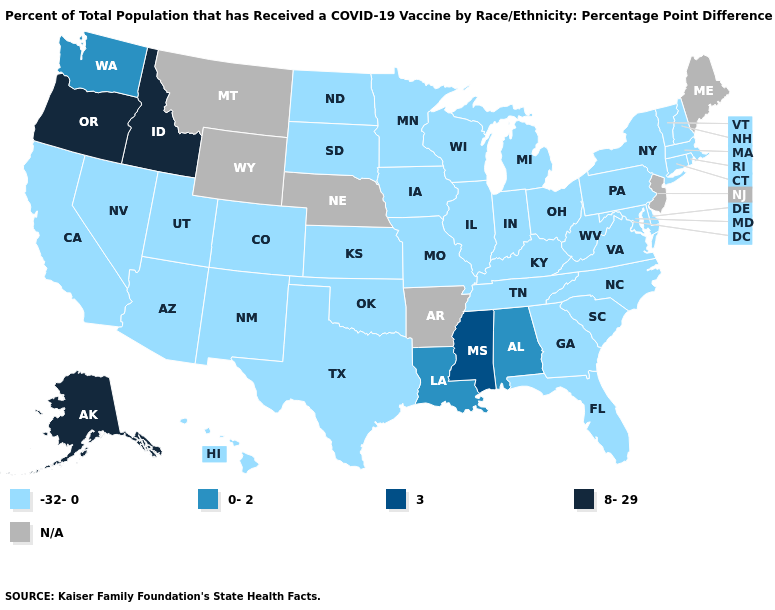Name the states that have a value in the range 0-2?
Give a very brief answer. Alabama, Louisiana, Washington. What is the value of Oklahoma?
Write a very short answer. -32-0. Among the states that border New Mexico , which have the highest value?
Keep it brief. Arizona, Colorado, Oklahoma, Texas, Utah. Does Kansas have the lowest value in the USA?
Give a very brief answer. Yes. Which states have the highest value in the USA?
Keep it brief. Alaska, Idaho, Oregon. What is the value of Minnesota?
Be succinct. -32-0. What is the highest value in the South ?
Be succinct. 3. What is the value of Kansas?
Be succinct. -32-0. What is the value of Washington?
Concise answer only. 0-2. Name the states that have a value in the range -32-0?
Short answer required. Arizona, California, Colorado, Connecticut, Delaware, Florida, Georgia, Hawaii, Illinois, Indiana, Iowa, Kansas, Kentucky, Maryland, Massachusetts, Michigan, Minnesota, Missouri, Nevada, New Hampshire, New Mexico, New York, North Carolina, North Dakota, Ohio, Oklahoma, Pennsylvania, Rhode Island, South Carolina, South Dakota, Tennessee, Texas, Utah, Vermont, Virginia, West Virginia, Wisconsin. Among the states that border Pennsylvania , which have the lowest value?
Short answer required. Delaware, Maryland, New York, Ohio, West Virginia. Does Oregon have the highest value in the USA?
Write a very short answer. Yes. What is the value of Utah?
Give a very brief answer. -32-0. Does Oklahoma have the lowest value in the USA?
Short answer required. Yes. 